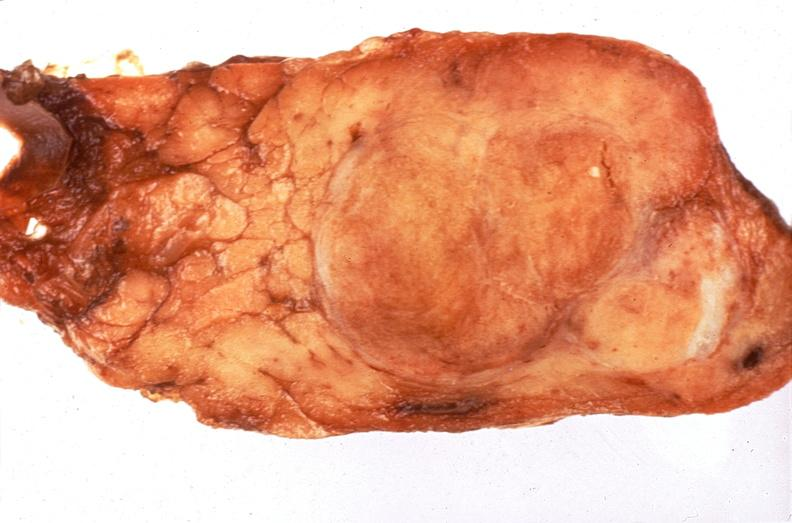does this image show pituitary, chromaphobe adenoma?
Answer the question using a single word or phrase. Yes 